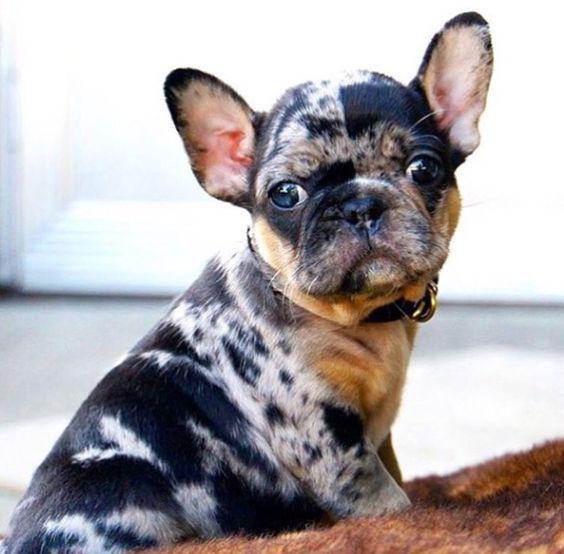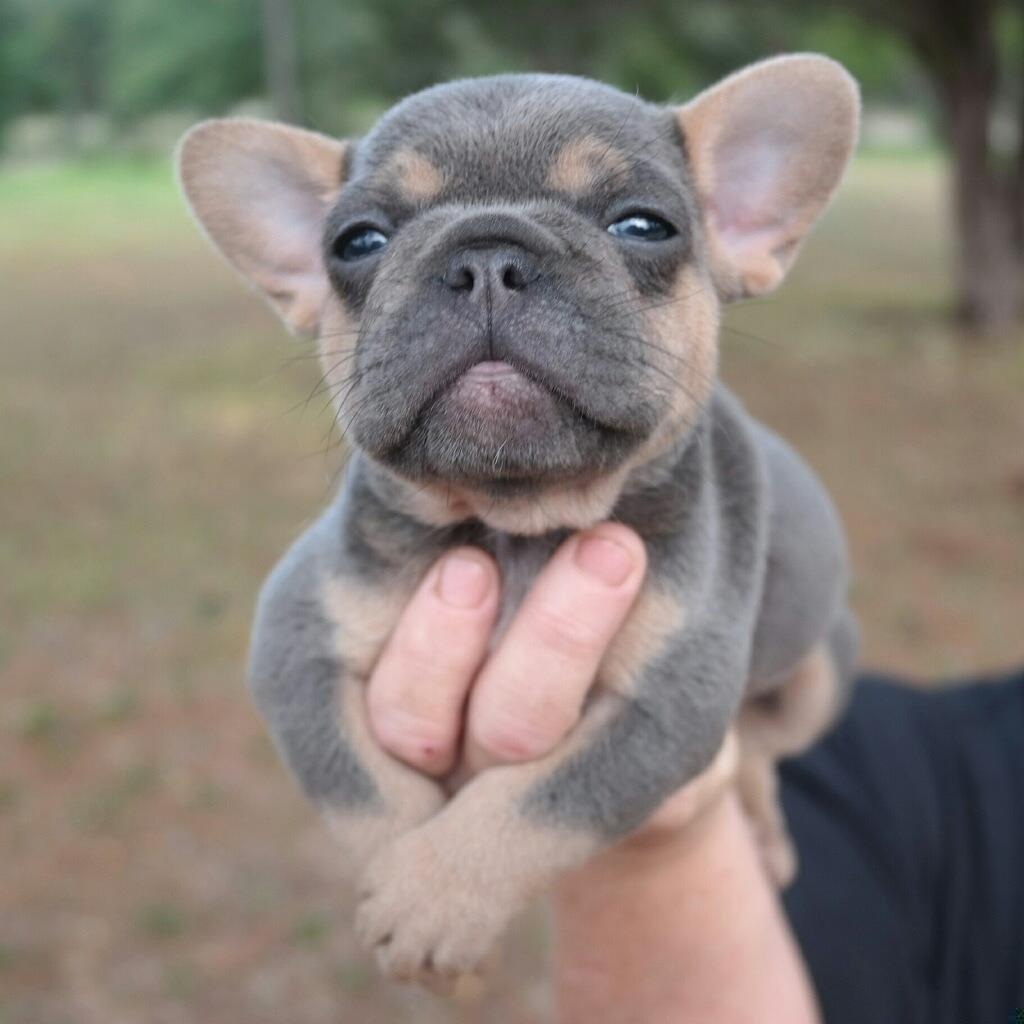The first image is the image on the left, the second image is the image on the right. Examine the images to the left and right. Is the description "One of the images features a dog that is wearing a collar." accurate? Answer yes or no. Yes. The first image is the image on the left, the second image is the image on the right. Evaluate the accuracy of this statement regarding the images: "Each image contains a single dog, which is gazing toward the front and has its mouth closed.". Is it true? Answer yes or no. Yes. 